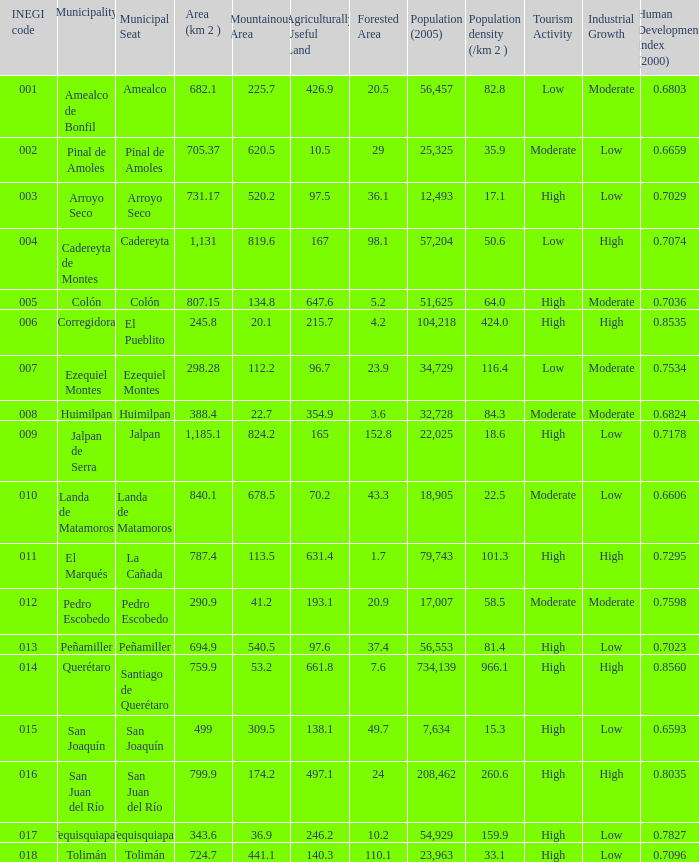WHat is the amount of Human Development Index (2000) that has a Population (2005) of 54,929, and an Area (km 2 ) larger than 343.6? 0.0. 